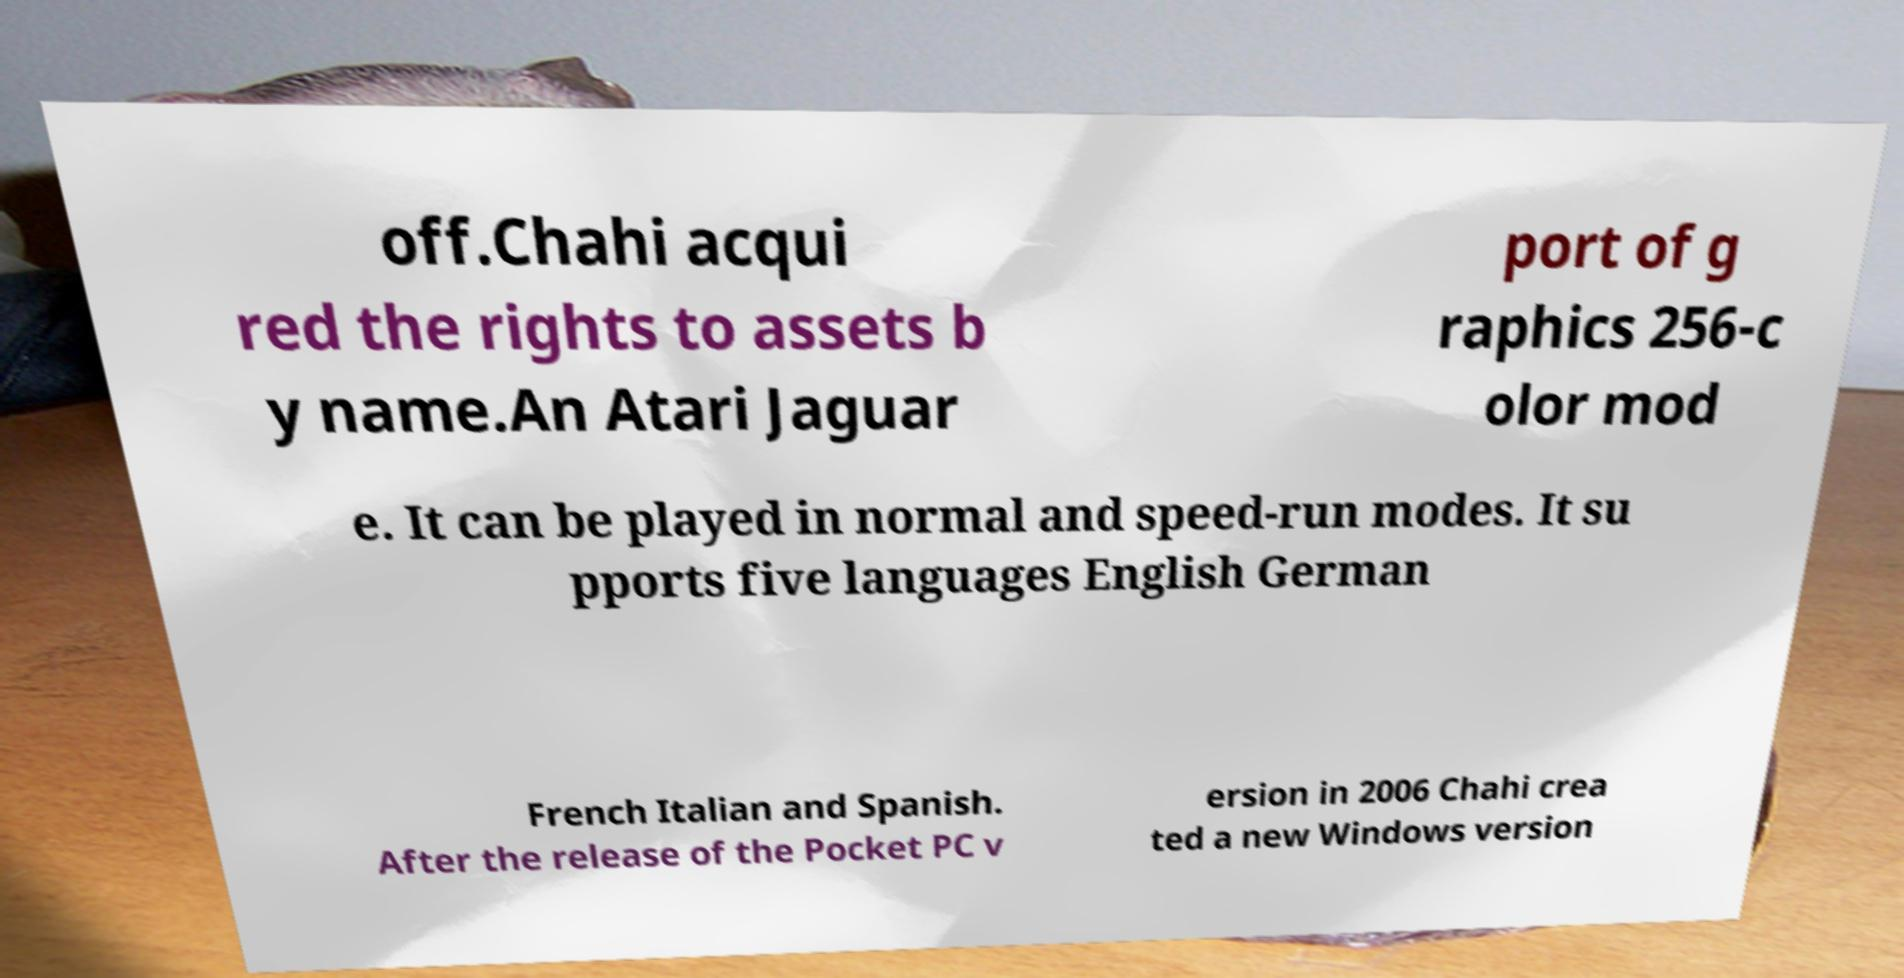What messages or text are displayed in this image? I need them in a readable, typed format. off.Chahi acqui red the rights to assets b y name.An Atari Jaguar port of g raphics 256-c olor mod e. It can be played in normal and speed-run modes. It su pports five languages English German French Italian and Spanish. After the release of the Pocket PC v ersion in 2006 Chahi crea ted a new Windows version 